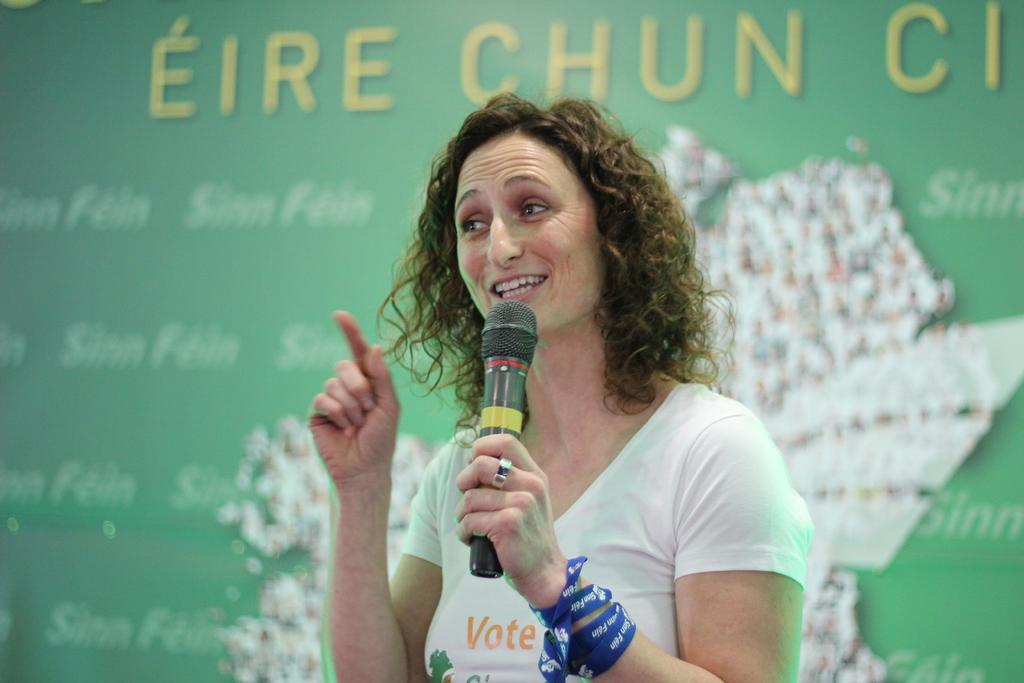Who is the main subject in the image? There is a woman in the image. What is the woman doing in the image? The woman is standing and talking. What is the woman wearing in the image? The woman is wearing a white T-shirt. What object is the woman holding in the image? The woman is holding a microphone. What can be seen in the background of the image? There is a green color banner in the background. What is written on the banner in the image? The banner has some words on it. What advertisement can be seen on the calendar in the image? There is no calendar present in the image, and therefore no advertisement can be observed. 